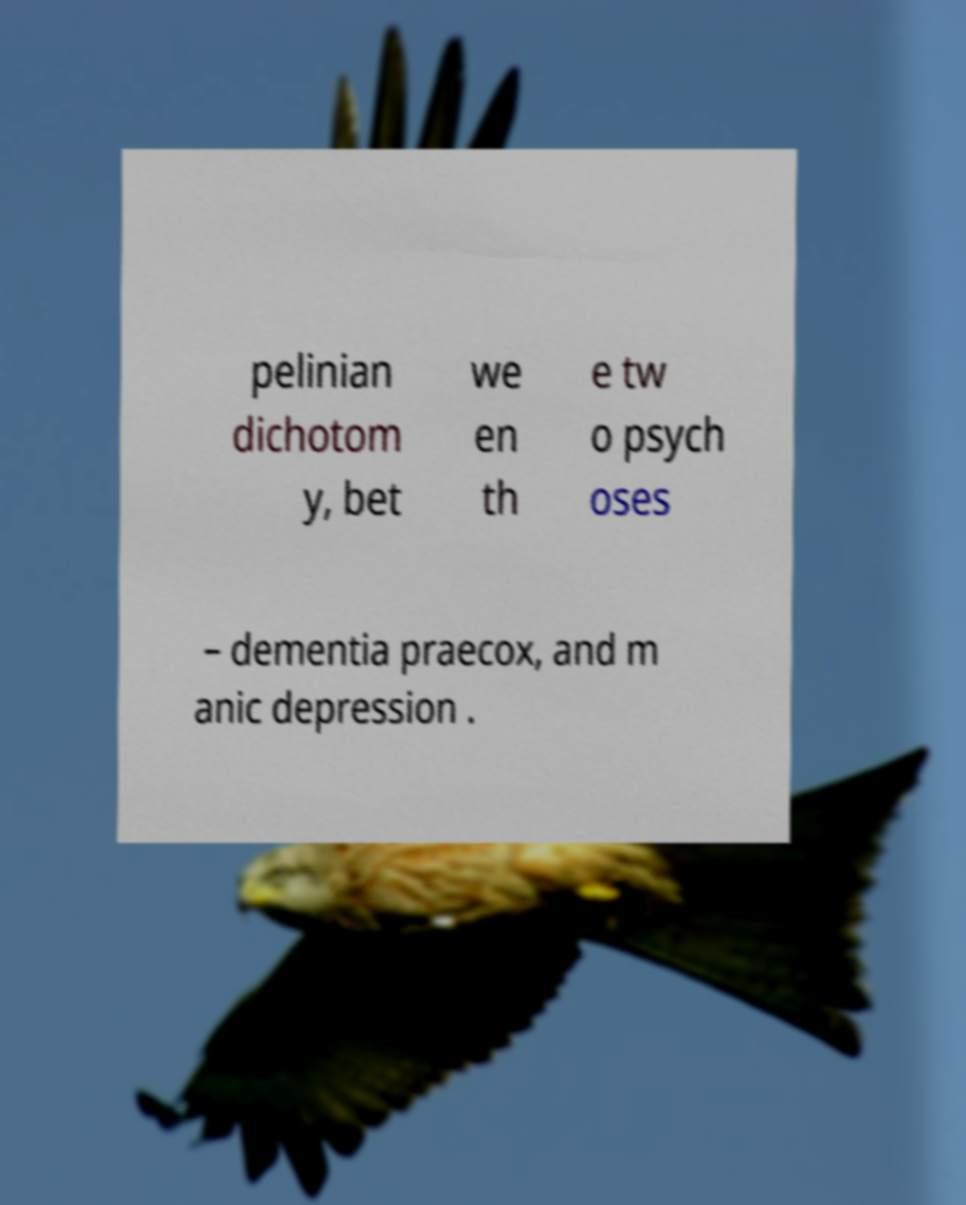For documentation purposes, I need the text within this image transcribed. Could you provide that? pelinian dichotom y, bet we en th e tw o psych oses – dementia praecox, and m anic depression . 